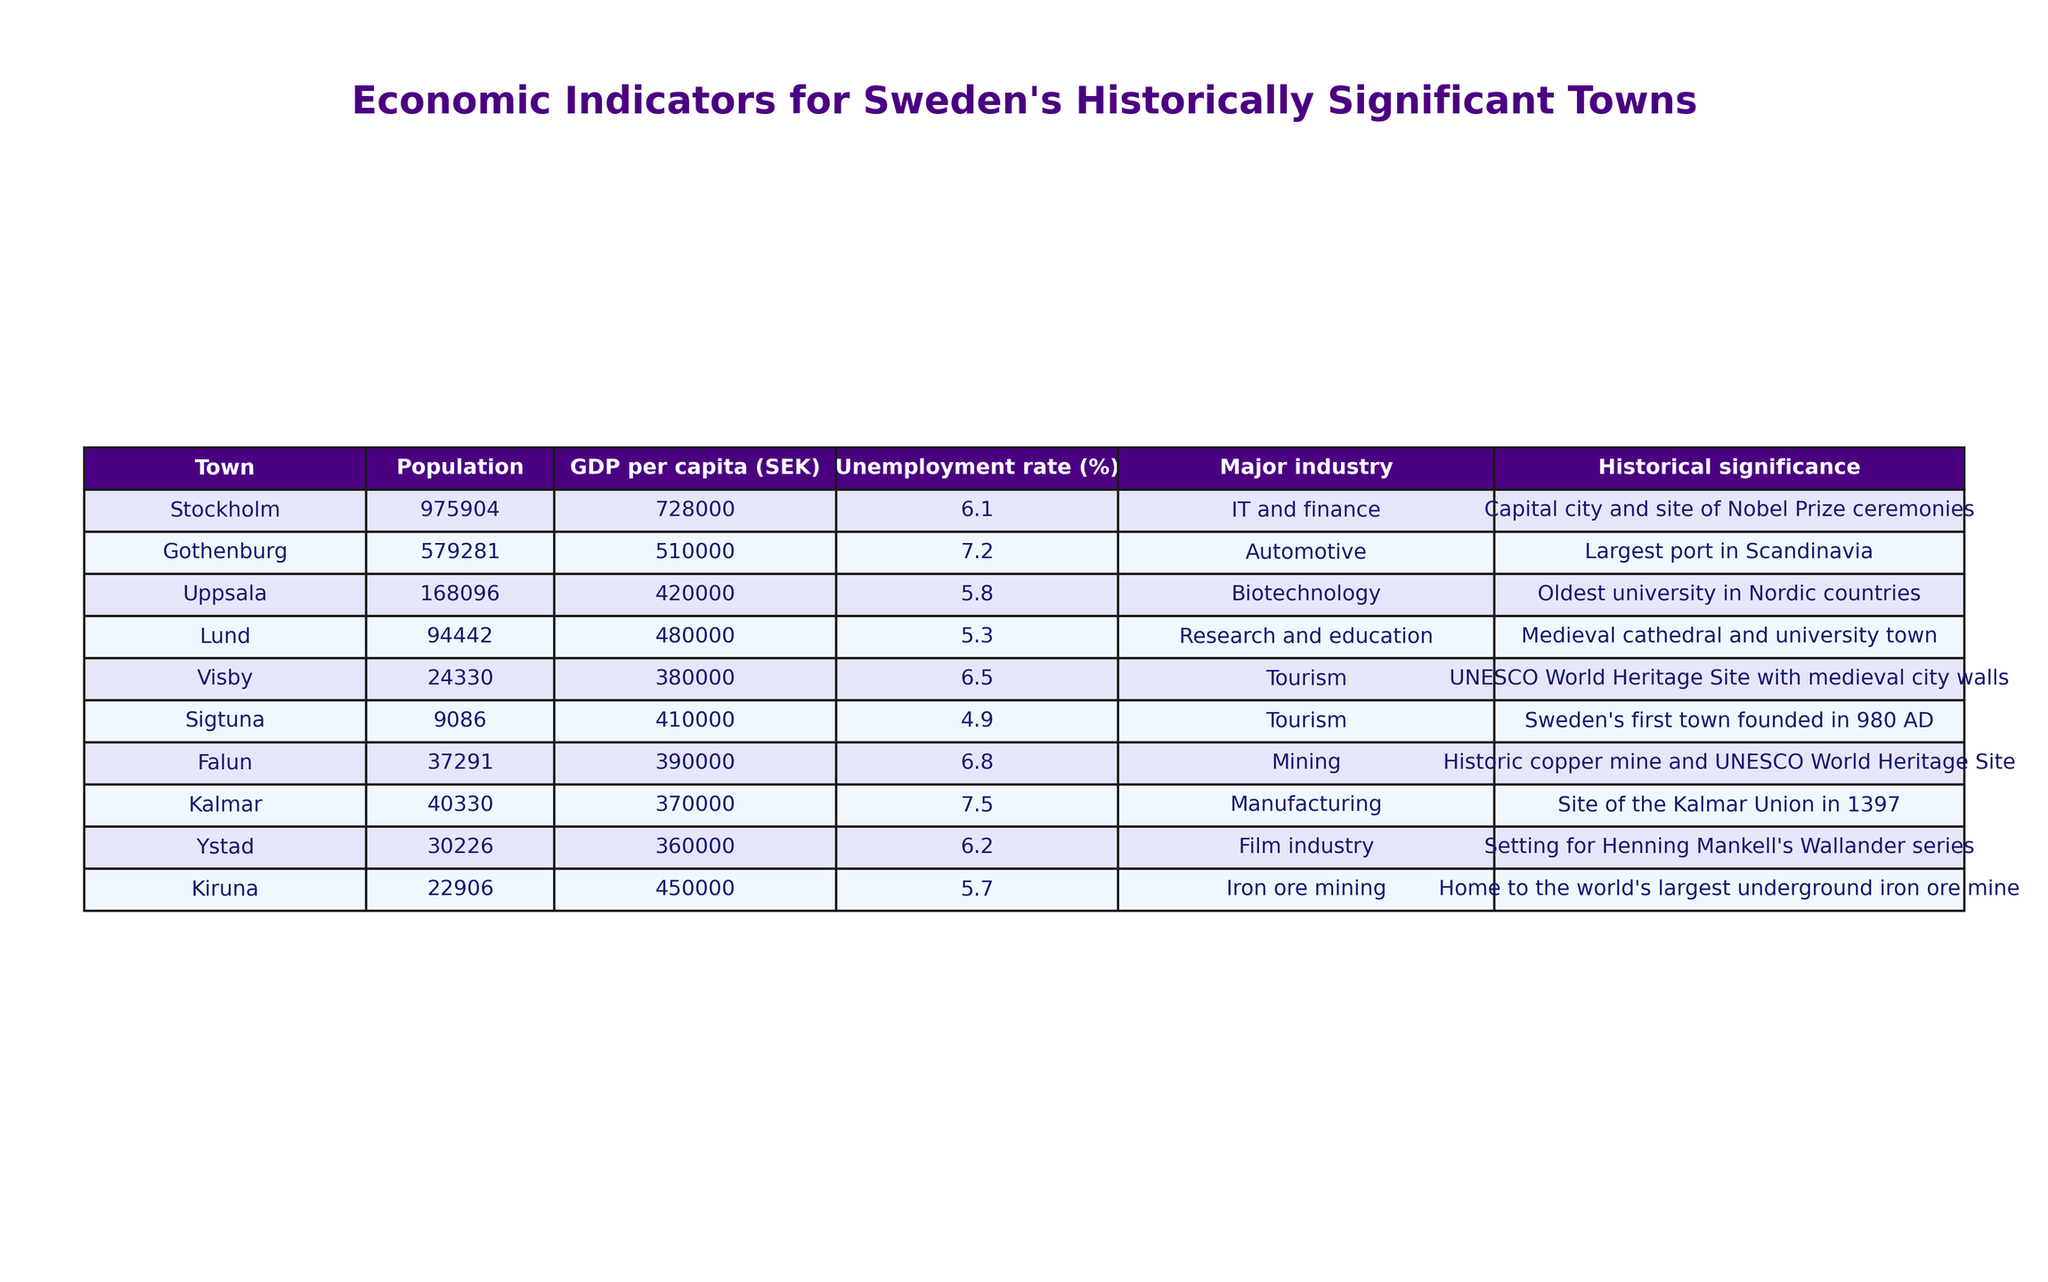What is the population of Stockholm? The population of Stockholm is listed in the table under the Population column next to Stockholm. It shows the value as 975,904.
Answer: 975904 Which town has the highest GDP per capita? By looking at the GDP per capita column, we find Stockholm has the highest value at 728,000 SEK compared to the other towns.
Answer: Stockholm What is the unemployment rate of Visby? The unemployment rate for Visby is provided in the table under the corresponding column, which shows a value of 6.5%.
Answer: 6.5% How many towns have a GDP per capita exceeding 500,000 SEK? By counting the towns from the GDP per capita column, we see that three towns - Stockholm, Gothenburg, and Kiruna - exceed 500,000 SEK.
Answer: 3 Does Sigtuna have a higher unemployment rate than Uppsala? The unemployment rate for Sigtuna is 4.9% and for Uppsala, it is 5.8%. Comparing these, Sigtuna has a lower unemployment rate.
Answer: No Which town has the lowest population? The population for each town is noted, and after comparing, Sigtuna has the lowest population at 9,086.
Answer: Sigtuna Calculate the average GDP per capita of the towns listed. To find the average, we sum the GDP per capita of all towns and divide by the number of towns (8). The total is 3,699,000 SEK, leading to an average of 462,375 SEK.
Answer: 462375 Is the historical significance of Lund related to its university? Lund is described in the table as a university town, indicating its historical significance is indeed related to education.
Answer: Yes Which industry employs the most in Uppsala and what is its GDP per capita? The table indicates that biotechnology is the major industry in Uppsala, with a GDP per capita of 420,000 SEK.
Answer: Biotechnology, 420000 Find the difference in unemployment rates between Kalmar and Falun. The unemployment rate for Kalmar is 7.5% and for Falun, it is 6.8%. Calculating the difference gives us 7.5% - 6.8% = 0.7%.
Answer: 0.7% 